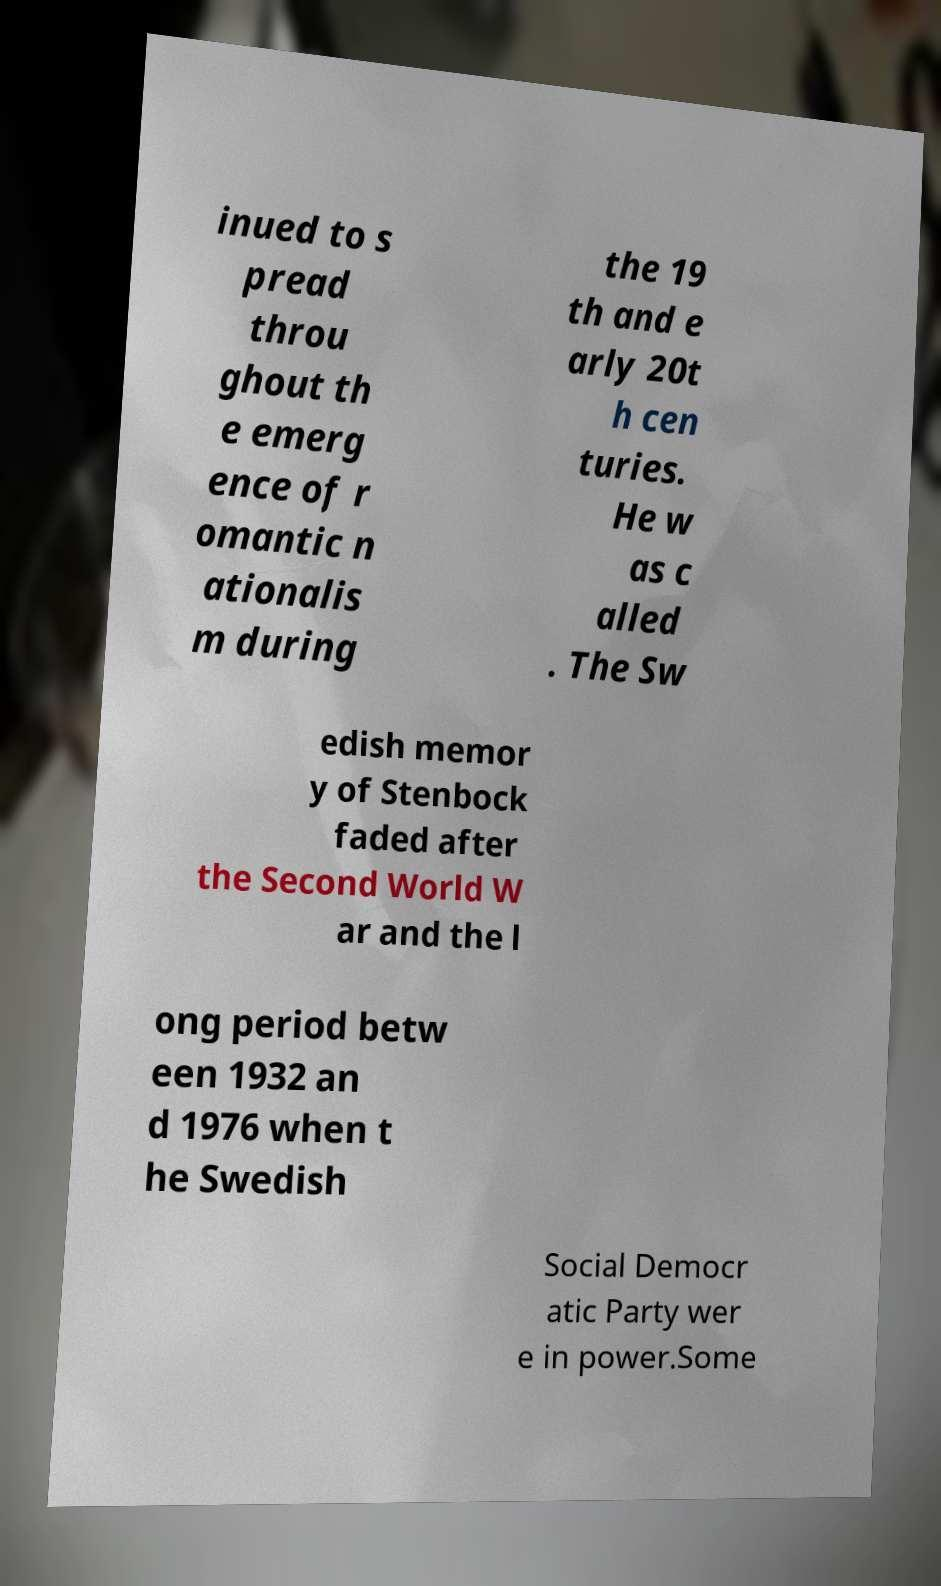Could you assist in decoding the text presented in this image and type it out clearly? inued to s pread throu ghout th e emerg ence of r omantic n ationalis m during the 19 th and e arly 20t h cen turies. He w as c alled . The Sw edish memor y of Stenbock faded after the Second World W ar and the l ong period betw een 1932 an d 1976 when t he Swedish Social Democr atic Party wer e in power.Some 